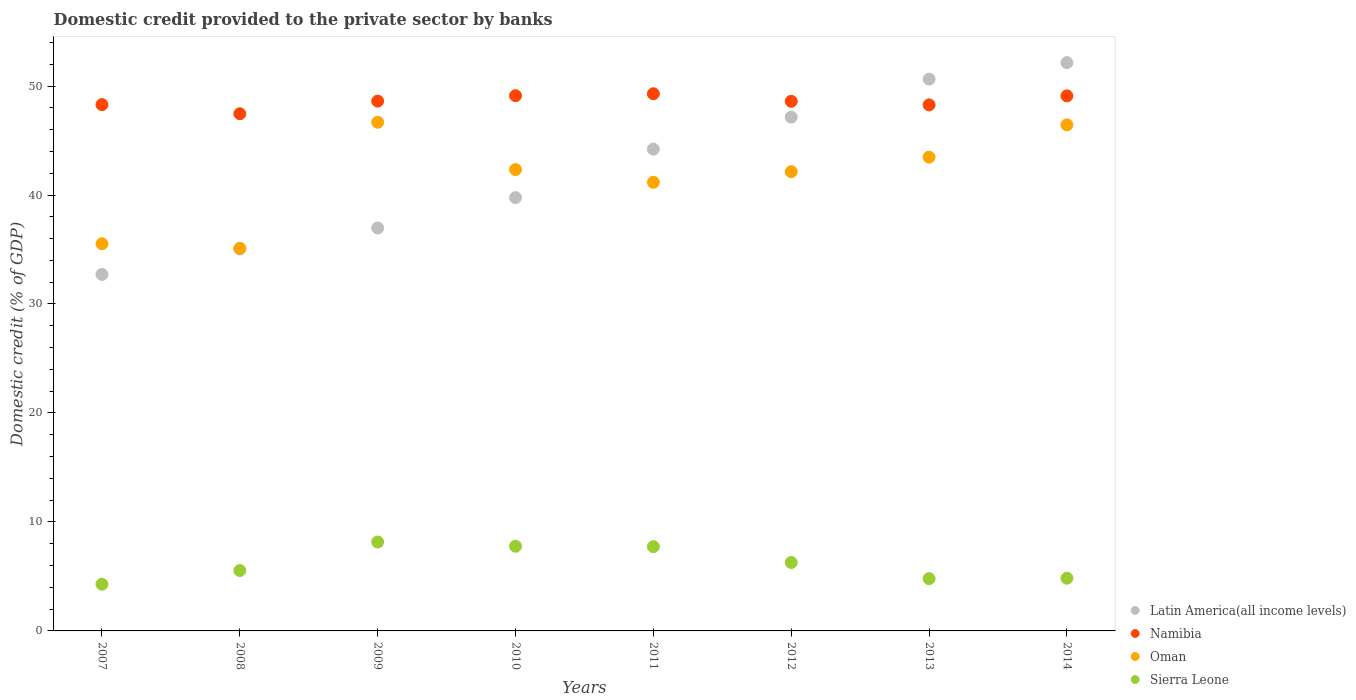How many different coloured dotlines are there?
Provide a short and direct response. 4. What is the domestic credit provided to the private sector by banks in Latin America(all income levels) in 2007?
Give a very brief answer. 32.71. Across all years, what is the maximum domestic credit provided to the private sector by banks in Sierra Leone?
Provide a succinct answer. 8.16. Across all years, what is the minimum domestic credit provided to the private sector by banks in Oman?
Provide a succinct answer. 35.11. What is the total domestic credit provided to the private sector by banks in Oman in the graph?
Your response must be concise. 332.86. What is the difference between the domestic credit provided to the private sector by banks in Oman in 2009 and that in 2010?
Make the answer very short. 4.34. What is the difference between the domestic credit provided to the private sector by banks in Latin America(all income levels) in 2009 and the domestic credit provided to the private sector by banks in Sierra Leone in 2008?
Keep it short and to the point. 31.44. What is the average domestic credit provided to the private sector by banks in Sierra Leone per year?
Your response must be concise. 6.17. In the year 2010, what is the difference between the domestic credit provided to the private sector by banks in Latin America(all income levels) and domestic credit provided to the private sector by banks in Oman?
Provide a short and direct response. -2.58. In how many years, is the domestic credit provided to the private sector by banks in Namibia greater than 2 %?
Your answer should be very brief. 8. What is the ratio of the domestic credit provided to the private sector by banks in Latin America(all income levels) in 2009 to that in 2014?
Your answer should be very brief. 0.71. What is the difference between the highest and the second highest domestic credit provided to the private sector by banks in Sierra Leone?
Offer a terse response. 0.39. What is the difference between the highest and the lowest domestic credit provided to the private sector by banks in Namibia?
Ensure brevity in your answer.  1.83. Is it the case that in every year, the sum of the domestic credit provided to the private sector by banks in Namibia and domestic credit provided to the private sector by banks in Sierra Leone  is greater than the sum of domestic credit provided to the private sector by banks in Latin America(all income levels) and domestic credit provided to the private sector by banks in Oman?
Your response must be concise. No. Is it the case that in every year, the sum of the domestic credit provided to the private sector by banks in Sierra Leone and domestic credit provided to the private sector by banks in Namibia  is greater than the domestic credit provided to the private sector by banks in Oman?
Offer a terse response. Yes. Does the domestic credit provided to the private sector by banks in Latin America(all income levels) monotonically increase over the years?
Keep it short and to the point. Yes. How many years are there in the graph?
Your response must be concise. 8. What is the difference between two consecutive major ticks on the Y-axis?
Keep it short and to the point. 10. Are the values on the major ticks of Y-axis written in scientific E-notation?
Offer a terse response. No. What is the title of the graph?
Your response must be concise. Domestic credit provided to the private sector by banks. Does "Latvia" appear as one of the legend labels in the graph?
Keep it short and to the point. No. What is the label or title of the Y-axis?
Provide a succinct answer. Domestic credit (% of GDP). What is the Domestic credit (% of GDP) of Latin America(all income levels) in 2007?
Your answer should be compact. 32.71. What is the Domestic credit (% of GDP) in Namibia in 2007?
Provide a succinct answer. 48.29. What is the Domestic credit (% of GDP) in Oman in 2007?
Provide a succinct answer. 35.53. What is the Domestic credit (% of GDP) in Sierra Leone in 2007?
Provide a succinct answer. 4.28. What is the Domestic credit (% of GDP) in Latin America(all income levels) in 2008?
Offer a terse response. 35.06. What is the Domestic credit (% of GDP) in Namibia in 2008?
Offer a very short reply. 47.46. What is the Domestic credit (% of GDP) of Oman in 2008?
Your answer should be compact. 35.11. What is the Domestic credit (% of GDP) of Sierra Leone in 2008?
Ensure brevity in your answer.  5.54. What is the Domestic credit (% of GDP) of Latin America(all income levels) in 2009?
Make the answer very short. 36.98. What is the Domestic credit (% of GDP) of Namibia in 2009?
Your answer should be very brief. 48.62. What is the Domestic credit (% of GDP) in Oman in 2009?
Your answer should be very brief. 46.68. What is the Domestic credit (% of GDP) of Sierra Leone in 2009?
Keep it short and to the point. 8.16. What is the Domestic credit (% of GDP) of Latin America(all income levels) in 2010?
Provide a succinct answer. 39.76. What is the Domestic credit (% of GDP) in Namibia in 2010?
Ensure brevity in your answer.  49.11. What is the Domestic credit (% of GDP) of Oman in 2010?
Provide a short and direct response. 42.33. What is the Domestic credit (% of GDP) in Sierra Leone in 2010?
Make the answer very short. 7.77. What is the Domestic credit (% of GDP) in Latin America(all income levels) in 2011?
Offer a terse response. 44.21. What is the Domestic credit (% of GDP) of Namibia in 2011?
Give a very brief answer. 49.29. What is the Domestic credit (% of GDP) in Oman in 2011?
Your response must be concise. 41.17. What is the Domestic credit (% of GDP) of Sierra Leone in 2011?
Offer a terse response. 7.73. What is the Domestic credit (% of GDP) of Latin America(all income levels) in 2012?
Provide a succinct answer. 47.15. What is the Domestic credit (% of GDP) of Namibia in 2012?
Your answer should be very brief. 48.6. What is the Domestic credit (% of GDP) of Oman in 2012?
Make the answer very short. 42.14. What is the Domestic credit (% of GDP) in Sierra Leone in 2012?
Your answer should be very brief. 6.28. What is the Domestic credit (% of GDP) of Latin America(all income levels) in 2013?
Give a very brief answer. 50.63. What is the Domestic credit (% of GDP) of Namibia in 2013?
Keep it short and to the point. 48.27. What is the Domestic credit (% of GDP) of Oman in 2013?
Your answer should be very brief. 43.47. What is the Domestic credit (% of GDP) in Sierra Leone in 2013?
Your answer should be very brief. 4.79. What is the Domestic credit (% of GDP) of Latin America(all income levels) in 2014?
Offer a very short reply. 52.14. What is the Domestic credit (% of GDP) in Namibia in 2014?
Make the answer very short. 49.1. What is the Domestic credit (% of GDP) in Oman in 2014?
Offer a very short reply. 46.44. What is the Domestic credit (% of GDP) of Sierra Leone in 2014?
Your response must be concise. 4.84. Across all years, what is the maximum Domestic credit (% of GDP) in Latin America(all income levels)?
Provide a succinct answer. 52.14. Across all years, what is the maximum Domestic credit (% of GDP) in Namibia?
Your response must be concise. 49.29. Across all years, what is the maximum Domestic credit (% of GDP) of Oman?
Offer a very short reply. 46.68. Across all years, what is the maximum Domestic credit (% of GDP) in Sierra Leone?
Your answer should be compact. 8.16. Across all years, what is the minimum Domestic credit (% of GDP) of Latin America(all income levels)?
Keep it short and to the point. 32.71. Across all years, what is the minimum Domestic credit (% of GDP) of Namibia?
Offer a very short reply. 47.46. Across all years, what is the minimum Domestic credit (% of GDP) in Oman?
Provide a short and direct response. 35.11. Across all years, what is the minimum Domestic credit (% of GDP) in Sierra Leone?
Make the answer very short. 4.28. What is the total Domestic credit (% of GDP) of Latin America(all income levels) in the graph?
Provide a short and direct response. 338.63. What is the total Domestic credit (% of GDP) of Namibia in the graph?
Provide a succinct answer. 388.74. What is the total Domestic credit (% of GDP) of Oman in the graph?
Ensure brevity in your answer.  332.86. What is the total Domestic credit (% of GDP) of Sierra Leone in the graph?
Offer a terse response. 49.4. What is the difference between the Domestic credit (% of GDP) of Latin America(all income levels) in 2007 and that in 2008?
Ensure brevity in your answer.  -2.35. What is the difference between the Domestic credit (% of GDP) in Namibia in 2007 and that in 2008?
Offer a terse response. 0.84. What is the difference between the Domestic credit (% of GDP) of Oman in 2007 and that in 2008?
Ensure brevity in your answer.  0.42. What is the difference between the Domestic credit (% of GDP) in Sierra Leone in 2007 and that in 2008?
Keep it short and to the point. -1.25. What is the difference between the Domestic credit (% of GDP) of Latin America(all income levels) in 2007 and that in 2009?
Offer a very short reply. -4.27. What is the difference between the Domestic credit (% of GDP) in Namibia in 2007 and that in 2009?
Offer a terse response. -0.32. What is the difference between the Domestic credit (% of GDP) of Oman in 2007 and that in 2009?
Give a very brief answer. -11.15. What is the difference between the Domestic credit (% of GDP) of Sierra Leone in 2007 and that in 2009?
Keep it short and to the point. -3.87. What is the difference between the Domestic credit (% of GDP) in Latin America(all income levels) in 2007 and that in 2010?
Make the answer very short. -7.05. What is the difference between the Domestic credit (% of GDP) of Namibia in 2007 and that in 2010?
Make the answer very short. -0.82. What is the difference between the Domestic credit (% of GDP) in Oman in 2007 and that in 2010?
Your answer should be compact. -6.81. What is the difference between the Domestic credit (% of GDP) in Sierra Leone in 2007 and that in 2010?
Your answer should be compact. -3.49. What is the difference between the Domestic credit (% of GDP) of Latin America(all income levels) in 2007 and that in 2011?
Make the answer very short. -11.5. What is the difference between the Domestic credit (% of GDP) in Namibia in 2007 and that in 2011?
Give a very brief answer. -1. What is the difference between the Domestic credit (% of GDP) in Oman in 2007 and that in 2011?
Provide a short and direct response. -5.64. What is the difference between the Domestic credit (% of GDP) of Sierra Leone in 2007 and that in 2011?
Your response must be concise. -3.45. What is the difference between the Domestic credit (% of GDP) of Latin America(all income levels) in 2007 and that in 2012?
Your answer should be very brief. -14.44. What is the difference between the Domestic credit (% of GDP) of Namibia in 2007 and that in 2012?
Offer a terse response. -0.3. What is the difference between the Domestic credit (% of GDP) in Oman in 2007 and that in 2012?
Provide a short and direct response. -6.61. What is the difference between the Domestic credit (% of GDP) of Sierra Leone in 2007 and that in 2012?
Offer a very short reply. -1.99. What is the difference between the Domestic credit (% of GDP) in Latin America(all income levels) in 2007 and that in 2013?
Provide a short and direct response. -17.93. What is the difference between the Domestic credit (% of GDP) in Namibia in 2007 and that in 2013?
Your response must be concise. 0.02. What is the difference between the Domestic credit (% of GDP) in Oman in 2007 and that in 2013?
Keep it short and to the point. -7.95. What is the difference between the Domestic credit (% of GDP) of Sierra Leone in 2007 and that in 2013?
Make the answer very short. -0.51. What is the difference between the Domestic credit (% of GDP) of Latin America(all income levels) in 2007 and that in 2014?
Ensure brevity in your answer.  -19.44. What is the difference between the Domestic credit (% of GDP) in Namibia in 2007 and that in 2014?
Make the answer very short. -0.8. What is the difference between the Domestic credit (% of GDP) of Oman in 2007 and that in 2014?
Give a very brief answer. -10.91. What is the difference between the Domestic credit (% of GDP) in Sierra Leone in 2007 and that in 2014?
Give a very brief answer. -0.55. What is the difference between the Domestic credit (% of GDP) in Latin America(all income levels) in 2008 and that in 2009?
Offer a terse response. -1.92. What is the difference between the Domestic credit (% of GDP) of Namibia in 2008 and that in 2009?
Provide a short and direct response. -1.16. What is the difference between the Domestic credit (% of GDP) of Oman in 2008 and that in 2009?
Your response must be concise. -11.57. What is the difference between the Domestic credit (% of GDP) of Sierra Leone in 2008 and that in 2009?
Keep it short and to the point. -2.62. What is the difference between the Domestic credit (% of GDP) of Latin America(all income levels) in 2008 and that in 2010?
Your answer should be very brief. -4.7. What is the difference between the Domestic credit (% of GDP) of Namibia in 2008 and that in 2010?
Make the answer very short. -1.65. What is the difference between the Domestic credit (% of GDP) of Oman in 2008 and that in 2010?
Give a very brief answer. -7.23. What is the difference between the Domestic credit (% of GDP) in Sierra Leone in 2008 and that in 2010?
Give a very brief answer. -2.23. What is the difference between the Domestic credit (% of GDP) in Latin America(all income levels) in 2008 and that in 2011?
Provide a succinct answer. -9.15. What is the difference between the Domestic credit (% of GDP) in Namibia in 2008 and that in 2011?
Offer a very short reply. -1.83. What is the difference between the Domestic credit (% of GDP) of Oman in 2008 and that in 2011?
Your answer should be compact. -6.06. What is the difference between the Domestic credit (% of GDP) in Sierra Leone in 2008 and that in 2011?
Provide a short and direct response. -2.19. What is the difference between the Domestic credit (% of GDP) of Latin America(all income levels) in 2008 and that in 2012?
Offer a very short reply. -12.09. What is the difference between the Domestic credit (% of GDP) in Namibia in 2008 and that in 2012?
Provide a short and direct response. -1.14. What is the difference between the Domestic credit (% of GDP) in Oman in 2008 and that in 2012?
Your response must be concise. -7.03. What is the difference between the Domestic credit (% of GDP) of Sierra Leone in 2008 and that in 2012?
Provide a short and direct response. -0.74. What is the difference between the Domestic credit (% of GDP) of Latin America(all income levels) in 2008 and that in 2013?
Give a very brief answer. -15.58. What is the difference between the Domestic credit (% of GDP) of Namibia in 2008 and that in 2013?
Keep it short and to the point. -0.81. What is the difference between the Domestic credit (% of GDP) in Oman in 2008 and that in 2013?
Your answer should be very brief. -8.36. What is the difference between the Domestic credit (% of GDP) in Sierra Leone in 2008 and that in 2013?
Your response must be concise. 0.74. What is the difference between the Domestic credit (% of GDP) in Latin America(all income levels) in 2008 and that in 2014?
Offer a terse response. -17.09. What is the difference between the Domestic credit (% of GDP) of Namibia in 2008 and that in 2014?
Provide a succinct answer. -1.64. What is the difference between the Domestic credit (% of GDP) in Oman in 2008 and that in 2014?
Provide a short and direct response. -11.33. What is the difference between the Domestic credit (% of GDP) of Sierra Leone in 2008 and that in 2014?
Make the answer very short. 0.7. What is the difference between the Domestic credit (% of GDP) of Latin America(all income levels) in 2009 and that in 2010?
Offer a very short reply. -2.78. What is the difference between the Domestic credit (% of GDP) in Namibia in 2009 and that in 2010?
Offer a very short reply. -0.49. What is the difference between the Domestic credit (% of GDP) of Oman in 2009 and that in 2010?
Your answer should be very brief. 4.34. What is the difference between the Domestic credit (% of GDP) of Sierra Leone in 2009 and that in 2010?
Make the answer very short. 0.39. What is the difference between the Domestic credit (% of GDP) in Latin America(all income levels) in 2009 and that in 2011?
Your response must be concise. -7.23. What is the difference between the Domestic credit (% of GDP) of Namibia in 2009 and that in 2011?
Give a very brief answer. -0.67. What is the difference between the Domestic credit (% of GDP) in Oman in 2009 and that in 2011?
Your answer should be very brief. 5.51. What is the difference between the Domestic credit (% of GDP) of Sierra Leone in 2009 and that in 2011?
Provide a short and direct response. 0.43. What is the difference between the Domestic credit (% of GDP) in Latin America(all income levels) in 2009 and that in 2012?
Ensure brevity in your answer.  -10.17. What is the difference between the Domestic credit (% of GDP) of Namibia in 2009 and that in 2012?
Ensure brevity in your answer.  0.02. What is the difference between the Domestic credit (% of GDP) in Oman in 2009 and that in 2012?
Offer a terse response. 4.54. What is the difference between the Domestic credit (% of GDP) in Sierra Leone in 2009 and that in 2012?
Provide a short and direct response. 1.88. What is the difference between the Domestic credit (% of GDP) in Latin America(all income levels) in 2009 and that in 2013?
Offer a terse response. -13.66. What is the difference between the Domestic credit (% of GDP) of Namibia in 2009 and that in 2013?
Offer a very short reply. 0.35. What is the difference between the Domestic credit (% of GDP) of Oman in 2009 and that in 2013?
Your answer should be compact. 3.2. What is the difference between the Domestic credit (% of GDP) in Sierra Leone in 2009 and that in 2013?
Your answer should be very brief. 3.36. What is the difference between the Domestic credit (% of GDP) in Latin America(all income levels) in 2009 and that in 2014?
Offer a terse response. -15.17. What is the difference between the Domestic credit (% of GDP) in Namibia in 2009 and that in 2014?
Keep it short and to the point. -0.48. What is the difference between the Domestic credit (% of GDP) in Oman in 2009 and that in 2014?
Offer a terse response. 0.24. What is the difference between the Domestic credit (% of GDP) in Sierra Leone in 2009 and that in 2014?
Keep it short and to the point. 3.32. What is the difference between the Domestic credit (% of GDP) of Latin America(all income levels) in 2010 and that in 2011?
Keep it short and to the point. -4.45. What is the difference between the Domestic credit (% of GDP) in Namibia in 2010 and that in 2011?
Provide a short and direct response. -0.18. What is the difference between the Domestic credit (% of GDP) in Oman in 2010 and that in 2011?
Your response must be concise. 1.17. What is the difference between the Domestic credit (% of GDP) of Sierra Leone in 2010 and that in 2011?
Give a very brief answer. 0.04. What is the difference between the Domestic credit (% of GDP) of Latin America(all income levels) in 2010 and that in 2012?
Provide a succinct answer. -7.39. What is the difference between the Domestic credit (% of GDP) of Namibia in 2010 and that in 2012?
Ensure brevity in your answer.  0.51. What is the difference between the Domestic credit (% of GDP) in Oman in 2010 and that in 2012?
Make the answer very short. 0.19. What is the difference between the Domestic credit (% of GDP) in Sierra Leone in 2010 and that in 2012?
Provide a short and direct response. 1.49. What is the difference between the Domestic credit (% of GDP) of Latin America(all income levels) in 2010 and that in 2013?
Your answer should be very brief. -10.88. What is the difference between the Domestic credit (% of GDP) of Namibia in 2010 and that in 2013?
Your response must be concise. 0.84. What is the difference between the Domestic credit (% of GDP) of Oman in 2010 and that in 2013?
Provide a succinct answer. -1.14. What is the difference between the Domestic credit (% of GDP) in Sierra Leone in 2010 and that in 2013?
Your response must be concise. 2.98. What is the difference between the Domestic credit (% of GDP) of Latin America(all income levels) in 2010 and that in 2014?
Provide a short and direct response. -12.39. What is the difference between the Domestic credit (% of GDP) in Namibia in 2010 and that in 2014?
Keep it short and to the point. 0.02. What is the difference between the Domestic credit (% of GDP) of Oman in 2010 and that in 2014?
Offer a very short reply. -4.1. What is the difference between the Domestic credit (% of GDP) in Sierra Leone in 2010 and that in 2014?
Give a very brief answer. 2.93. What is the difference between the Domestic credit (% of GDP) of Latin America(all income levels) in 2011 and that in 2012?
Provide a short and direct response. -2.94. What is the difference between the Domestic credit (% of GDP) of Namibia in 2011 and that in 2012?
Give a very brief answer. 0.69. What is the difference between the Domestic credit (% of GDP) of Oman in 2011 and that in 2012?
Provide a short and direct response. -0.97. What is the difference between the Domestic credit (% of GDP) of Sierra Leone in 2011 and that in 2012?
Keep it short and to the point. 1.45. What is the difference between the Domestic credit (% of GDP) in Latin America(all income levels) in 2011 and that in 2013?
Your response must be concise. -6.43. What is the difference between the Domestic credit (% of GDP) of Namibia in 2011 and that in 2013?
Your response must be concise. 1.02. What is the difference between the Domestic credit (% of GDP) in Oman in 2011 and that in 2013?
Make the answer very short. -2.31. What is the difference between the Domestic credit (% of GDP) in Sierra Leone in 2011 and that in 2013?
Provide a succinct answer. 2.94. What is the difference between the Domestic credit (% of GDP) of Latin America(all income levels) in 2011 and that in 2014?
Provide a short and direct response. -7.94. What is the difference between the Domestic credit (% of GDP) in Namibia in 2011 and that in 2014?
Offer a terse response. 0.19. What is the difference between the Domestic credit (% of GDP) in Oman in 2011 and that in 2014?
Provide a succinct answer. -5.27. What is the difference between the Domestic credit (% of GDP) in Sierra Leone in 2011 and that in 2014?
Offer a terse response. 2.89. What is the difference between the Domestic credit (% of GDP) of Latin America(all income levels) in 2012 and that in 2013?
Ensure brevity in your answer.  -3.49. What is the difference between the Domestic credit (% of GDP) in Namibia in 2012 and that in 2013?
Your answer should be compact. 0.33. What is the difference between the Domestic credit (% of GDP) of Oman in 2012 and that in 2013?
Your answer should be very brief. -1.33. What is the difference between the Domestic credit (% of GDP) of Sierra Leone in 2012 and that in 2013?
Ensure brevity in your answer.  1.48. What is the difference between the Domestic credit (% of GDP) of Latin America(all income levels) in 2012 and that in 2014?
Provide a succinct answer. -5. What is the difference between the Domestic credit (% of GDP) in Namibia in 2012 and that in 2014?
Your answer should be very brief. -0.5. What is the difference between the Domestic credit (% of GDP) of Oman in 2012 and that in 2014?
Provide a short and direct response. -4.3. What is the difference between the Domestic credit (% of GDP) of Sierra Leone in 2012 and that in 2014?
Provide a short and direct response. 1.44. What is the difference between the Domestic credit (% of GDP) in Latin America(all income levels) in 2013 and that in 2014?
Offer a very short reply. -1.51. What is the difference between the Domestic credit (% of GDP) of Namibia in 2013 and that in 2014?
Your answer should be very brief. -0.82. What is the difference between the Domestic credit (% of GDP) in Oman in 2013 and that in 2014?
Ensure brevity in your answer.  -2.97. What is the difference between the Domestic credit (% of GDP) in Sierra Leone in 2013 and that in 2014?
Keep it short and to the point. -0.04. What is the difference between the Domestic credit (% of GDP) in Latin America(all income levels) in 2007 and the Domestic credit (% of GDP) in Namibia in 2008?
Make the answer very short. -14.75. What is the difference between the Domestic credit (% of GDP) of Latin America(all income levels) in 2007 and the Domestic credit (% of GDP) of Oman in 2008?
Your response must be concise. -2.4. What is the difference between the Domestic credit (% of GDP) of Latin America(all income levels) in 2007 and the Domestic credit (% of GDP) of Sierra Leone in 2008?
Ensure brevity in your answer.  27.17. What is the difference between the Domestic credit (% of GDP) of Namibia in 2007 and the Domestic credit (% of GDP) of Oman in 2008?
Keep it short and to the point. 13.19. What is the difference between the Domestic credit (% of GDP) of Namibia in 2007 and the Domestic credit (% of GDP) of Sierra Leone in 2008?
Keep it short and to the point. 42.76. What is the difference between the Domestic credit (% of GDP) in Oman in 2007 and the Domestic credit (% of GDP) in Sierra Leone in 2008?
Offer a very short reply. 29.99. What is the difference between the Domestic credit (% of GDP) of Latin America(all income levels) in 2007 and the Domestic credit (% of GDP) of Namibia in 2009?
Your answer should be very brief. -15.91. What is the difference between the Domestic credit (% of GDP) of Latin America(all income levels) in 2007 and the Domestic credit (% of GDP) of Oman in 2009?
Offer a terse response. -13.97. What is the difference between the Domestic credit (% of GDP) of Latin America(all income levels) in 2007 and the Domestic credit (% of GDP) of Sierra Leone in 2009?
Give a very brief answer. 24.55. What is the difference between the Domestic credit (% of GDP) of Namibia in 2007 and the Domestic credit (% of GDP) of Oman in 2009?
Provide a succinct answer. 1.62. What is the difference between the Domestic credit (% of GDP) in Namibia in 2007 and the Domestic credit (% of GDP) in Sierra Leone in 2009?
Your response must be concise. 40.14. What is the difference between the Domestic credit (% of GDP) of Oman in 2007 and the Domestic credit (% of GDP) of Sierra Leone in 2009?
Ensure brevity in your answer.  27.37. What is the difference between the Domestic credit (% of GDP) of Latin America(all income levels) in 2007 and the Domestic credit (% of GDP) of Namibia in 2010?
Your answer should be very brief. -16.4. What is the difference between the Domestic credit (% of GDP) of Latin America(all income levels) in 2007 and the Domestic credit (% of GDP) of Oman in 2010?
Give a very brief answer. -9.63. What is the difference between the Domestic credit (% of GDP) in Latin America(all income levels) in 2007 and the Domestic credit (% of GDP) in Sierra Leone in 2010?
Ensure brevity in your answer.  24.94. What is the difference between the Domestic credit (% of GDP) in Namibia in 2007 and the Domestic credit (% of GDP) in Oman in 2010?
Provide a short and direct response. 5.96. What is the difference between the Domestic credit (% of GDP) of Namibia in 2007 and the Domestic credit (% of GDP) of Sierra Leone in 2010?
Make the answer very short. 40.52. What is the difference between the Domestic credit (% of GDP) of Oman in 2007 and the Domestic credit (% of GDP) of Sierra Leone in 2010?
Provide a succinct answer. 27.76. What is the difference between the Domestic credit (% of GDP) in Latin America(all income levels) in 2007 and the Domestic credit (% of GDP) in Namibia in 2011?
Give a very brief answer. -16.58. What is the difference between the Domestic credit (% of GDP) of Latin America(all income levels) in 2007 and the Domestic credit (% of GDP) of Oman in 2011?
Your response must be concise. -8.46. What is the difference between the Domestic credit (% of GDP) in Latin America(all income levels) in 2007 and the Domestic credit (% of GDP) in Sierra Leone in 2011?
Your answer should be compact. 24.98. What is the difference between the Domestic credit (% of GDP) in Namibia in 2007 and the Domestic credit (% of GDP) in Oman in 2011?
Provide a short and direct response. 7.13. What is the difference between the Domestic credit (% of GDP) of Namibia in 2007 and the Domestic credit (% of GDP) of Sierra Leone in 2011?
Keep it short and to the point. 40.56. What is the difference between the Domestic credit (% of GDP) of Oman in 2007 and the Domestic credit (% of GDP) of Sierra Leone in 2011?
Your answer should be compact. 27.8. What is the difference between the Domestic credit (% of GDP) in Latin America(all income levels) in 2007 and the Domestic credit (% of GDP) in Namibia in 2012?
Provide a succinct answer. -15.89. What is the difference between the Domestic credit (% of GDP) of Latin America(all income levels) in 2007 and the Domestic credit (% of GDP) of Oman in 2012?
Keep it short and to the point. -9.43. What is the difference between the Domestic credit (% of GDP) of Latin America(all income levels) in 2007 and the Domestic credit (% of GDP) of Sierra Leone in 2012?
Your response must be concise. 26.43. What is the difference between the Domestic credit (% of GDP) in Namibia in 2007 and the Domestic credit (% of GDP) in Oman in 2012?
Your response must be concise. 6.15. What is the difference between the Domestic credit (% of GDP) in Namibia in 2007 and the Domestic credit (% of GDP) in Sierra Leone in 2012?
Your answer should be compact. 42.02. What is the difference between the Domestic credit (% of GDP) of Oman in 2007 and the Domestic credit (% of GDP) of Sierra Leone in 2012?
Provide a short and direct response. 29.25. What is the difference between the Domestic credit (% of GDP) of Latin America(all income levels) in 2007 and the Domestic credit (% of GDP) of Namibia in 2013?
Ensure brevity in your answer.  -15.56. What is the difference between the Domestic credit (% of GDP) of Latin America(all income levels) in 2007 and the Domestic credit (% of GDP) of Oman in 2013?
Ensure brevity in your answer.  -10.76. What is the difference between the Domestic credit (% of GDP) of Latin America(all income levels) in 2007 and the Domestic credit (% of GDP) of Sierra Leone in 2013?
Make the answer very short. 27.91. What is the difference between the Domestic credit (% of GDP) in Namibia in 2007 and the Domestic credit (% of GDP) in Oman in 2013?
Give a very brief answer. 4.82. What is the difference between the Domestic credit (% of GDP) in Namibia in 2007 and the Domestic credit (% of GDP) in Sierra Leone in 2013?
Ensure brevity in your answer.  43.5. What is the difference between the Domestic credit (% of GDP) of Oman in 2007 and the Domestic credit (% of GDP) of Sierra Leone in 2013?
Offer a very short reply. 30.73. What is the difference between the Domestic credit (% of GDP) of Latin America(all income levels) in 2007 and the Domestic credit (% of GDP) of Namibia in 2014?
Keep it short and to the point. -16.39. What is the difference between the Domestic credit (% of GDP) in Latin America(all income levels) in 2007 and the Domestic credit (% of GDP) in Oman in 2014?
Keep it short and to the point. -13.73. What is the difference between the Domestic credit (% of GDP) of Latin America(all income levels) in 2007 and the Domestic credit (% of GDP) of Sierra Leone in 2014?
Provide a succinct answer. 27.87. What is the difference between the Domestic credit (% of GDP) of Namibia in 2007 and the Domestic credit (% of GDP) of Oman in 2014?
Provide a short and direct response. 1.86. What is the difference between the Domestic credit (% of GDP) in Namibia in 2007 and the Domestic credit (% of GDP) in Sierra Leone in 2014?
Offer a terse response. 43.46. What is the difference between the Domestic credit (% of GDP) in Oman in 2007 and the Domestic credit (% of GDP) in Sierra Leone in 2014?
Provide a succinct answer. 30.69. What is the difference between the Domestic credit (% of GDP) of Latin America(all income levels) in 2008 and the Domestic credit (% of GDP) of Namibia in 2009?
Offer a terse response. -13.56. What is the difference between the Domestic credit (% of GDP) in Latin America(all income levels) in 2008 and the Domestic credit (% of GDP) in Oman in 2009?
Your answer should be very brief. -11.62. What is the difference between the Domestic credit (% of GDP) of Latin America(all income levels) in 2008 and the Domestic credit (% of GDP) of Sierra Leone in 2009?
Your answer should be very brief. 26.9. What is the difference between the Domestic credit (% of GDP) of Namibia in 2008 and the Domestic credit (% of GDP) of Oman in 2009?
Ensure brevity in your answer.  0.78. What is the difference between the Domestic credit (% of GDP) in Namibia in 2008 and the Domestic credit (% of GDP) in Sierra Leone in 2009?
Provide a short and direct response. 39.3. What is the difference between the Domestic credit (% of GDP) of Oman in 2008 and the Domestic credit (% of GDP) of Sierra Leone in 2009?
Provide a succinct answer. 26.95. What is the difference between the Domestic credit (% of GDP) of Latin America(all income levels) in 2008 and the Domestic credit (% of GDP) of Namibia in 2010?
Give a very brief answer. -14.05. What is the difference between the Domestic credit (% of GDP) in Latin America(all income levels) in 2008 and the Domestic credit (% of GDP) in Oman in 2010?
Provide a short and direct response. -7.28. What is the difference between the Domestic credit (% of GDP) in Latin America(all income levels) in 2008 and the Domestic credit (% of GDP) in Sierra Leone in 2010?
Ensure brevity in your answer.  27.29. What is the difference between the Domestic credit (% of GDP) of Namibia in 2008 and the Domestic credit (% of GDP) of Oman in 2010?
Keep it short and to the point. 5.12. What is the difference between the Domestic credit (% of GDP) in Namibia in 2008 and the Domestic credit (% of GDP) in Sierra Leone in 2010?
Your answer should be very brief. 39.69. What is the difference between the Domestic credit (% of GDP) of Oman in 2008 and the Domestic credit (% of GDP) of Sierra Leone in 2010?
Make the answer very short. 27.34. What is the difference between the Domestic credit (% of GDP) in Latin America(all income levels) in 2008 and the Domestic credit (% of GDP) in Namibia in 2011?
Keep it short and to the point. -14.23. What is the difference between the Domestic credit (% of GDP) in Latin America(all income levels) in 2008 and the Domestic credit (% of GDP) in Oman in 2011?
Your response must be concise. -6.11. What is the difference between the Domestic credit (% of GDP) of Latin America(all income levels) in 2008 and the Domestic credit (% of GDP) of Sierra Leone in 2011?
Offer a terse response. 27.32. What is the difference between the Domestic credit (% of GDP) in Namibia in 2008 and the Domestic credit (% of GDP) in Oman in 2011?
Keep it short and to the point. 6.29. What is the difference between the Domestic credit (% of GDP) of Namibia in 2008 and the Domestic credit (% of GDP) of Sierra Leone in 2011?
Your answer should be very brief. 39.72. What is the difference between the Domestic credit (% of GDP) of Oman in 2008 and the Domestic credit (% of GDP) of Sierra Leone in 2011?
Provide a succinct answer. 27.38. What is the difference between the Domestic credit (% of GDP) of Latin America(all income levels) in 2008 and the Domestic credit (% of GDP) of Namibia in 2012?
Your response must be concise. -13.54. What is the difference between the Domestic credit (% of GDP) of Latin America(all income levels) in 2008 and the Domestic credit (% of GDP) of Oman in 2012?
Your answer should be compact. -7.08. What is the difference between the Domestic credit (% of GDP) of Latin America(all income levels) in 2008 and the Domestic credit (% of GDP) of Sierra Leone in 2012?
Your answer should be compact. 28.78. What is the difference between the Domestic credit (% of GDP) in Namibia in 2008 and the Domestic credit (% of GDP) in Oman in 2012?
Make the answer very short. 5.32. What is the difference between the Domestic credit (% of GDP) of Namibia in 2008 and the Domestic credit (% of GDP) of Sierra Leone in 2012?
Keep it short and to the point. 41.18. What is the difference between the Domestic credit (% of GDP) of Oman in 2008 and the Domestic credit (% of GDP) of Sierra Leone in 2012?
Your response must be concise. 28.83. What is the difference between the Domestic credit (% of GDP) of Latin America(all income levels) in 2008 and the Domestic credit (% of GDP) of Namibia in 2013?
Keep it short and to the point. -13.21. What is the difference between the Domestic credit (% of GDP) of Latin America(all income levels) in 2008 and the Domestic credit (% of GDP) of Oman in 2013?
Your answer should be very brief. -8.42. What is the difference between the Domestic credit (% of GDP) in Latin America(all income levels) in 2008 and the Domestic credit (% of GDP) in Sierra Leone in 2013?
Your answer should be compact. 30.26. What is the difference between the Domestic credit (% of GDP) in Namibia in 2008 and the Domestic credit (% of GDP) in Oman in 2013?
Ensure brevity in your answer.  3.98. What is the difference between the Domestic credit (% of GDP) in Namibia in 2008 and the Domestic credit (% of GDP) in Sierra Leone in 2013?
Make the answer very short. 42.66. What is the difference between the Domestic credit (% of GDP) in Oman in 2008 and the Domestic credit (% of GDP) in Sierra Leone in 2013?
Offer a terse response. 30.31. What is the difference between the Domestic credit (% of GDP) in Latin America(all income levels) in 2008 and the Domestic credit (% of GDP) in Namibia in 2014?
Your response must be concise. -14.04. What is the difference between the Domestic credit (% of GDP) of Latin America(all income levels) in 2008 and the Domestic credit (% of GDP) of Oman in 2014?
Provide a succinct answer. -11.38. What is the difference between the Domestic credit (% of GDP) in Latin America(all income levels) in 2008 and the Domestic credit (% of GDP) in Sierra Leone in 2014?
Your answer should be very brief. 30.22. What is the difference between the Domestic credit (% of GDP) in Namibia in 2008 and the Domestic credit (% of GDP) in Oman in 2014?
Offer a very short reply. 1.02. What is the difference between the Domestic credit (% of GDP) in Namibia in 2008 and the Domestic credit (% of GDP) in Sierra Leone in 2014?
Offer a terse response. 42.62. What is the difference between the Domestic credit (% of GDP) of Oman in 2008 and the Domestic credit (% of GDP) of Sierra Leone in 2014?
Give a very brief answer. 30.27. What is the difference between the Domestic credit (% of GDP) in Latin America(all income levels) in 2009 and the Domestic credit (% of GDP) in Namibia in 2010?
Provide a short and direct response. -12.14. What is the difference between the Domestic credit (% of GDP) of Latin America(all income levels) in 2009 and the Domestic credit (% of GDP) of Oman in 2010?
Offer a very short reply. -5.36. What is the difference between the Domestic credit (% of GDP) of Latin America(all income levels) in 2009 and the Domestic credit (% of GDP) of Sierra Leone in 2010?
Your answer should be very brief. 29.2. What is the difference between the Domestic credit (% of GDP) in Namibia in 2009 and the Domestic credit (% of GDP) in Oman in 2010?
Make the answer very short. 6.28. What is the difference between the Domestic credit (% of GDP) of Namibia in 2009 and the Domestic credit (% of GDP) of Sierra Leone in 2010?
Provide a succinct answer. 40.85. What is the difference between the Domestic credit (% of GDP) of Oman in 2009 and the Domestic credit (% of GDP) of Sierra Leone in 2010?
Provide a succinct answer. 38.9. What is the difference between the Domestic credit (% of GDP) of Latin America(all income levels) in 2009 and the Domestic credit (% of GDP) of Namibia in 2011?
Your response must be concise. -12.31. What is the difference between the Domestic credit (% of GDP) in Latin America(all income levels) in 2009 and the Domestic credit (% of GDP) in Oman in 2011?
Your answer should be compact. -4.19. What is the difference between the Domestic credit (% of GDP) of Latin America(all income levels) in 2009 and the Domestic credit (% of GDP) of Sierra Leone in 2011?
Ensure brevity in your answer.  29.24. What is the difference between the Domestic credit (% of GDP) in Namibia in 2009 and the Domestic credit (% of GDP) in Oman in 2011?
Your response must be concise. 7.45. What is the difference between the Domestic credit (% of GDP) in Namibia in 2009 and the Domestic credit (% of GDP) in Sierra Leone in 2011?
Ensure brevity in your answer.  40.89. What is the difference between the Domestic credit (% of GDP) in Oman in 2009 and the Domestic credit (% of GDP) in Sierra Leone in 2011?
Your answer should be compact. 38.94. What is the difference between the Domestic credit (% of GDP) in Latin America(all income levels) in 2009 and the Domestic credit (% of GDP) in Namibia in 2012?
Your answer should be compact. -11.62. What is the difference between the Domestic credit (% of GDP) in Latin America(all income levels) in 2009 and the Domestic credit (% of GDP) in Oman in 2012?
Offer a very short reply. -5.16. What is the difference between the Domestic credit (% of GDP) of Latin America(all income levels) in 2009 and the Domestic credit (% of GDP) of Sierra Leone in 2012?
Provide a short and direct response. 30.7. What is the difference between the Domestic credit (% of GDP) of Namibia in 2009 and the Domestic credit (% of GDP) of Oman in 2012?
Your answer should be very brief. 6.48. What is the difference between the Domestic credit (% of GDP) of Namibia in 2009 and the Domestic credit (% of GDP) of Sierra Leone in 2012?
Give a very brief answer. 42.34. What is the difference between the Domestic credit (% of GDP) in Oman in 2009 and the Domestic credit (% of GDP) in Sierra Leone in 2012?
Keep it short and to the point. 40.4. What is the difference between the Domestic credit (% of GDP) in Latin America(all income levels) in 2009 and the Domestic credit (% of GDP) in Namibia in 2013?
Keep it short and to the point. -11.3. What is the difference between the Domestic credit (% of GDP) in Latin America(all income levels) in 2009 and the Domestic credit (% of GDP) in Oman in 2013?
Offer a terse response. -6.5. What is the difference between the Domestic credit (% of GDP) in Latin America(all income levels) in 2009 and the Domestic credit (% of GDP) in Sierra Leone in 2013?
Your answer should be compact. 32.18. What is the difference between the Domestic credit (% of GDP) of Namibia in 2009 and the Domestic credit (% of GDP) of Oman in 2013?
Offer a very short reply. 5.15. What is the difference between the Domestic credit (% of GDP) of Namibia in 2009 and the Domestic credit (% of GDP) of Sierra Leone in 2013?
Offer a very short reply. 43.82. What is the difference between the Domestic credit (% of GDP) in Oman in 2009 and the Domestic credit (% of GDP) in Sierra Leone in 2013?
Offer a terse response. 41.88. What is the difference between the Domestic credit (% of GDP) of Latin America(all income levels) in 2009 and the Domestic credit (% of GDP) of Namibia in 2014?
Make the answer very short. -12.12. What is the difference between the Domestic credit (% of GDP) in Latin America(all income levels) in 2009 and the Domestic credit (% of GDP) in Oman in 2014?
Provide a short and direct response. -9.46. What is the difference between the Domestic credit (% of GDP) in Latin America(all income levels) in 2009 and the Domestic credit (% of GDP) in Sierra Leone in 2014?
Offer a very short reply. 32.14. What is the difference between the Domestic credit (% of GDP) of Namibia in 2009 and the Domestic credit (% of GDP) of Oman in 2014?
Your response must be concise. 2.18. What is the difference between the Domestic credit (% of GDP) of Namibia in 2009 and the Domestic credit (% of GDP) of Sierra Leone in 2014?
Provide a short and direct response. 43.78. What is the difference between the Domestic credit (% of GDP) of Oman in 2009 and the Domestic credit (% of GDP) of Sierra Leone in 2014?
Offer a very short reply. 41.84. What is the difference between the Domestic credit (% of GDP) of Latin America(all income levels) in 2010 and the Domestic credit (% of GDP) of Namibia in 2011?
Provide a short and direct response. -9.53. What is the difference between the Domestic credit (% of GDP) of Latin America(all income levels) in 2010 and the Domestic credit (% of GDP) of Oman in 2011?
Ensure brevity in your answer.  -1.41. What is the difference between the Domestic credit (% of GDP) in Latin America(all income levels) in 2010 and the Domestic credit (% of GDP) in Sierra Leone in 2011?
Keep it short and to the point. 32.02. What is the difference between the Domestic credit (% of GDP) of Namibia in 2010 and the Domestic credit (% of GDP) of Oman in 2011?
Make the answer very short. 7.95. What is the difference between the Domestic credit (% of GDP) of Namibia in 2010 and the Domestic credit (% of GDP) of Sierra Leone in 2011?
Give a very brief answer. 41.38. What is the difference between the Domestic credit (% of GDP) in Oman in 2010 and the Domestic credit (% of GDP) in Sierra Leone in 2011?
Offer a terse response. 34.6. What is the difference between the Domestic credit (% of GDP) in Latin America(all income levels) in 2010 and the Domestic credit (% of GDP) in Namibia in 2012?
Provide a succinct answer. -8.84. What is the difference between the Domestic credit (% of GDP) of Latin America(all income levels) in 2010 and the Domestic credit (% of GDP) of Oman in 2012?
Your response must be concise. -2.38. What is the difference between the Domestic credit (% of GDP) in Latin America(all income levels) in 2010 and the Domestic credit (% of GDP) in Sierra Leone in 2012?
Provide a short and direct response. 33.48. What is the difference between the Domestic credit (% of GDP) of Namibia in 2010 and the Domestic credit (% of GDP) of Oman in 2012?
Your response must be concise. 6.97. What is the difference between the Domestic credit (% of GDP) in Namibia in 2010 and the Domestic credit (% of GDP) in Sierra Leone in 2012?
Offer a very short reply. 42.83. What is the difference between the Domestic credit (% of GDP) in Oman in 2010 and the Domestic credit (% of GDP) in Sierra Leone in 2012?
Provide a succinct answer. 36.06. What is the difference between the Domestic credit (% of GDP) of Latin America(all income levels) in 2010 and the Domestic credit (% of GDP) of Namibia in 2013?
Your answer should be very brief. -8.52. What is the difference between the Domestic credit (% of GDP) in Latin America(all income levels) in 2010 and the Domestic credit (% of GDP) in Oman in 2013?
Offer a very short reply. -3.72. What is the difference between the Domestic credit (% of GDP) in Latin America(all income levels) in 2010 and the Domestic credit (% of GDP) in Sierra Leone in 2013?
Ensure brevity in your answer.  34.96. What is the difference between the Domestic credit (% of GDP) of Namibia in 2010 and the Domestic credit (% of GDP) of Oman in 2013?
Keep it short and to the point. 5.64. What is the difference between the Domestic credit (% of GDP) of Namibia in 2010 and the Domestic credit (% of GDP) of Sierra Leone in 2013?
Provide a succinct answer. 44.32. What is the difference between the Domestic credit (% of GDP) in Oman in 2010 and the Domestic credit (% of GDP) in Sierra Leone in 2013?
Provide a succinct answer. 37.54. What is the difference between the Domestic credit (% of GDP) of Latin America(all income levels) in 2010 and the Domestic credit (% of GDP) of Namibia in 2014?
Keep it short and to the point. -9.34. What is the difference between the Domestic credit (% of GDP) in Latin America(all income levels) in 2010 and the Domestic credit (% of GDP) in Oman in 2014?
Provide a short and direct response. -6.68. What is the difference between the Domestic credit (% of GDP) in Latin America(all income levels) in 2010 and the Domestic credit (% of GDP) in Sierra Leone in 2014?
Offer a terse response. 34.92. What is the difference between the Domestic credit (% of GDP) of Namibia in 2010 and the Domestic credit (% of GDP) of Oman in 2014?
Make the answer very short. 2.67. What is the difference between the Domestic credit (% of GDP) of Namibia in 2010 and the Domestic credit (% of GDP) of Sierra Leone in 2014?
Your response must be concise. 44.27. What is the difference between the Domestic credit (% of GDP) in Oman in 2010 and the Domestic credit (% of GDP) in Sierra Leone in 2014?
Your answer should be compact. 37.5. What is the difference between the Domestic credit (% of GDP) in Latin America(all income levels) in 2011 and the Domestic credit (% of GDP) in Namibia in 2012?
Offer a terse response. -4.39. What is the difference between the Domestic credit (% of GDP) of Latin America(all income levels) in 2011 and the Domestic credit (% of GDP) of Oman in 2012?
Provide a succinct answer. 2.07. What is the difference between the Domestic credit (% of GDP) in Latin America(all income levels) in 2011 and the Domestic credit (% of GDP) in Sierra Leone in 2012?
Offer a terse response. 37.93. What is the difference between the Domestic credit (% of GDP) in Namibia in 2011 and the Domestic credit (% of GDP) in Oman in 2012?
Your answer should be very brief. 7.15. What is the difference between the Domestic credit (% of GDP) in Namibia in 2011 and the Domestic credit (% of GDP) in Sierra Leone in 2012?
Your response must be concise. 43.01. What is the difference between the Domestic credit (% of GDP) of Oman in 2011 and the Domestic credit (% of GDP) of Sierra Leone in 2012?
Your response must be concise. 34.89. What is the difference between the Domestic credit (% of GDP) in Latin America(all income levels) in 2011 and the Domestic credit (% of GDP) in Namibia in 2013?
Keep it short and to the point. -4.06. What is the difference between the Domestic credit (% of GDP) of Latin America(all income levels) in 2011 and the Domestic credit (% of GDP) of Oman in 2013?
Your answer should be very brief. 0.74. What is the difference between the Domestic credit (% of GDP) of Latin America(all income levels) in 2011 and the Domestic credit (% of GDP) of Sierra Leone in 2013?
Your response must be concise. 39.41. What is the difference between the Domestic credit (% of GDP) of Namibia in 2011 and the Domestic credit (% of GDP) of Oman in 2013?
Ensure brevity in your answer.  5.82. What is the difference between the Domestic credit (% of GDP) of Namibia in 2011 and the Domestic credit (% of GDP) of Sierra Leone in 2013?
Offer a very short reply. 44.5. What is the difference between the Domestic credit (% of GDP) of Oman in 2011 and the Domestic credit (% of GDP) of Sierra Leone in 2013?
Your answer should be compact. 36.37. What is the difference between the Domestic credit (% of GDP) in Latin America(all income levels) in 2011 and the Domestic credit (% of GDP) in Namibia in 2014?
Your response must be concise. -4.89. What is the difference between the Domestic credit (% of GDP) in Latin America(all income levels) in 2011 and the Domestic credit (% of GDP) in Oman in 2014?
Provide a succinct answer. -2.23. What is the difference between the Domestic credit (% of GDP) in Latin America(all income levels) in 2011 and the Domestic credit (% of GDP) in Sierra Leone in 2014?
Your answer should be compact. 39.37. What is the difference between the Domestic credit (% of GDP) of Namibia in 2011 and the Domestic credit (% of GDP) of Oman in 2014?
Provide a short and direct response. 2.85. What is the difference between the Domestic credit (% of GDP) of Namibia in 2011 and the Domestic credit (% of GDP) of Sierra Leone in 2014?
Offer a terse response. 44.45. What is the difference between the Domestic credit (% of GDP) of Oman in 2011 and the Domestic credit (% of GDP) of Sierra Leone in 2014?
Ensure brevity in your answer.  36.33. What is the difference between the Domestic credit (% of GDP) in Latin America(all income levels) in 2012 and the Domestic credit (% of GDP) in Namibia in 2013?
Your response must be concise. -1.13. What is the difference between the Domestic credit (% of GDP) in Latin America(all income levels) in 2012 and the Domestic credit (% of GDP) in Oman in 2013?
Your answer should be compact. 3.67. What is the difference between the Domestic credit (% of GDP) of Latin America(all income levels) in 2012 and the Domestic credit (% of GDP) of Sierra Leone in 2013?
Give a very brief answer. 42.35. What is the difference between the Domestic credit (% of GDP) in Namibia in 2012 and the Domestic credit (% of GDP) in Oman in 2013?
Give a very brief answer. 5.13. What is the difference between the Domestic credit (% of GDP) of Namibia in 2012 and the Domestic credit (% of GDP) of Sierra Leone in 2013?
Provide a short and direct response. 43.8. What is the difference between the Domestic credit (% of GDP) of Oman in 2012 and the Domestic credit (% of GDP) of Sierra Leone in 2013?
Your answer should be very brief. 37.35. What is the difference between the Domestic credit (% of GDP) in Latin America(all income levels) in 2012 and the Domestic credit (% of GDP) in Namibia in 2014?
Provide a short and direct response. -1.95. What is the difference between the Domestic credit (% of GDP) in Latin America(all income levels) in 2012 and the Domestic credit (% of GDP) in Oman in 2014?
Provide a short and direct response. 0.71. What is the difference between the Domestic credit (% of GDP) in Latin America(all income levels) in 2012 and the Domestic credit (% of GDP) in Sierra Leone in 2014?
Keep it short and to the point. 42.31. What is the difference between the Domestic credit (% of GDP) in Namibia in 2012 and the Domestic credit (% of GDP) in Oman in 2014?
Provide a succinct answer. 2.16. What is the difference between the Domestic credit (% of GDP) of Namibia in 2012 and the Domestic credit (% of GDP) of Sierra Leone in 2014?
Your answer should be compact. 43.76. What is the difference between the Domestic credit (% of GDP) in Oman in 2012 and the Domestic credit (% of GDP) in Sierra Leone in 2014?
Keep it short and to the point. 37.3. What is the difference between the Domestic credit (% of GDP) in Latin America(all income levels) in 2013 and the Domestic credit (% of GDP) in Namibia in 2014?
Your response must be concise. 1.54. What is the difference between the Domestic credit (% of GDP) of Latin America(all income levels) in 2013 and the Domestic credit (% of GDP) of Oman in 2014?
Your response must be concise. 4.2. What is the difference between the Domestic credit (% of GDP) in Latin America(all income levels) in 2013 and the Domestic credit (% of GDP) in Sierra Leone in 2014?
Make the answer very short. 45.8. What is the difference between the Domestic credit (% of GDP) of Namibia in 2013 and the Domestic credit (% of GDP) of Oman in 2014?
Offer a very short reply. 1.83. What is the difference between the Domestic credit (% of GDP) in Namibia in 2013 and the Domestic credit (% of GDP) in Sierra Leone in 2014?
Provide a short and direct response. 43.43. What is the difference between the Domestic credit (% of GDP) in Oman in 2013 and the Domestic credit (% of GDP) in Sierra Leone in 2014?
Keep it short and to the point. 38.64. What is the average Domestic credit (% of GDP) of Latin America(all income levels) per year?
Make the answer very short. 42.33. What is the average Domestic credit (% of GDP) of Namibia per year?
Ensure brevity in your answer.  48.59. What is the average Domestic credit (% of GDP) in Oman per year?
Offer a very short reply. 41.61. What is the average Domestic credit (% of GDP) in Sierra Leone per year?
Offer a terse response. 6.17. In the year 2007, what is the difference between the Domestic credit (% of GDP) in Latin America(all income levels) and Domestic credit (% of GDP) in Namibia?
Offer a very short reply. -15.59. In the year 2007, what is the difference between the Domestic credit (% of GDP) in Latin America(all income levels) and Domestic credit (% of GDP) in Oman?
Your answer should be very brief. -2.82. In the year 2007, what is the difference between the Domestic credit (% of GDP) in Latin America(all income levels) and Domestic credit (% of GDP) in Sierra Leone?
Offer a terse response. 28.42. In the year 2007, what is the difference between the Domestic credit (% of GDP) of Namibia and Domestic credit (% of GDP) of Oman?
Your answer should be compact. 12.77. In the year 2007, what is the difference between the Domestic credit (% of GDP) of Namibia and Domestic credit (% of GDP) of Sierra Leone?
Provide a short and direct response. 44.01. In the year 2007, what is the difference between the Domestic credit (% of GDP) in Oman and Domestic credit (% of GDP) in Sierra Leone?
Give a very brief answer. 31.24. In the year 2008, what is the difference between the Domestic credit (% of GDP) of Latin America(all income levels) and Domestic credit (% of GDP) of Namibia?
Provide a succinct answer. -12.4. In the year 2008, what is the difference between the Domestic credit (% of GDP) in Latin America(all income levels) and Domestic credit (% of GDP) in Oman?
Offer a very short reply. -0.05. In the year 2008, what is the difference between the Domestic credit (% of GDP) in Latin America(all income levels) and Domestic credit (% of GDP) in Sierra Leone?
Offer a very short reply. 29.52. In the year 2008, what is the difference between the Domestic credit (% of GDP) of Namibia and Domestic credit (% of GDP) of Oman?
Give a very brief answer. 12.35. In the year 2008, what is the difference between the Domestic credit (% of GDP) of Namibia and Domestic credit (% of GDP) of Sierra Leone?
Your answer should be very brief. 41.92. In the year 2008, what is the difference between the Domestic credit (% of GDP) of Oman and Domestic credit (% of GDP) of Sierra Leone?
Provide a short and direct response. 29.57. In the year 2009, what is the difference between the Domestic credit (% of GDP) of Latin America(all income levels) and Domestic credit (% of GDP) of Namibia?
Provide a succinct answer. -11.64. In the year 2009, what is the difference between the Domestic credit (% of GDP) of Latin America(all income levels) and Domestic credit (% of GDP) of Oman?
Ensure brevity in your answer.  -9.7. In the year 2009, what is the difference between the Domestic credit (% of GDP) of Latin America(all income levels) and Domestic credit (% of GDP) of Sierra Leone?
Make the answer very short. 28.82. In the year 2009, what is the difference between the Domestic credit (% of GDP) in Namibia and Domestic credit (% of GDP) in Oman?
Keep it short and to the point. 1.94. In the year 2009, what is the difference between the Domestic credit (% of GDP) in Namibia and Domestic credit (% of GDP) in Sierra Leone?
Provide a short and direct response. 40.46. In the year 2009, what is the difference between the Domestic credit (% of GDP) of Oman and Domestic credit (% of GDP) of Sierra Leone?
Your answer should be very brief. 38.52. In the year 2010, what is the difference between the Domestic credit (% of GDP) in Latin America(all income levels) and Domestic credit (% of GDP) in Namibia?
Ensure brevity in your answer.  -9.36. In the year 2010, what is the difference between the Domestic credit (% of GDP) in Latin America(all income levels) and Domestic credit (% of GDP) in Oman?
Ensure brevity in your answer.  -2.58. In the year 2010, what is the difference between the Domestic credit (% of GDP) in Latin America(all income levels) and Domestic credit (% of GDP) in Sierra Leone?
Offer a very short reply. 31.98. In the year 2010, what is the difference between the Domestic credit (% of GDP) in Namibia and Domestic credit (% of GDP) in Oman?
Your answer should be very brief. 6.78. In the year 2010, what is the difference between the Domestic credit (% of GDP) of Namibia and Domestic credit (% of GDP) of Sierra Leone?
Your response must be concise. 41.34. In the year 2010, what is the difference between the Domestic credit (% of GDP) of Oman and Domestic credit (% of GDP) of Sierra Leone?
Offer a very short reply. 34.56. In the year 2011, what is the difference between the Domestic credit (% of GDP) in Latin America(all income levels) and Domestic credit (% of GDP) in Namibia?
Make the answer very short. -5.08. In the year 2011, what is the difference between the Domestic credit (% of GDP) in Latin America(all income levels) and Domestic credit (% of GDP) in Oman?
Your response must be concise. 3.04. In the year 2011, what is the difference between the Domestic credit (% of GDP) in Latin America(all income levels) and Domestic credit (% of GDP) in Sierra Leone?
Ensure brevity in your answer.  36.48. In the year 2011, what is the difference between the Domestic credit (% of GDP) in Namibia and Domestic credit (% of GDP) in Oman?
Make the answer very short. 8.12. In the year 2011, what is the difference between the Domestic credit (% of GDP) of Namibia and Domestic credit (% of GDP) of Sierra Leone?
Offer a terse response. 41.56. In the year 2011, what is the difference between the Domestic credit (% of GDP) of Oman and Domestic credit (% of GDP) of Sierra Leone?
Give a very brief answer. 33.43. In the year 2012, what is the difference between the Domestic credit (% of GDP) in Latin America(all income levels) and Domestic credit (% of GDP) in Namibia?
Keep it short and to the point. -1.45. In the year 2012, what is the difference between the Domestic credit (% of GDP) in Latin America(all income levels) and Domestic credit (% of GDP) in Oman?
Your answer should be compact. 5.01. In the year 2012, what is the difference between the Domestic credit (% of GDP) of Latin America(all income levels) and Domestic credit (% of GDP) of Sierra Leone?
Your answer should be compact. 40.87. In the year 2012, what is the difference between the Domestic credit (% of GDP) of Namibia and Domestic credit (% of GDP) of Oman?
Offer a very short reply. 6.46. In the year 2012, what is the difference between the Domestic credit (% of GDP) in Namibia and Domestic credit (% of GDP) in Sierra Leone?
Your answer should be compact. 42.32. In the year 2012, what is the difference between the Domestic credit (% of GDP) of Oman and Domestic credit (% of GDP) of Sierra Leone?
Your answer should be very brief. 35.86. In the year 2013, what is the difference between the Domestic credit (% of GDP) in Latin America(all income levels) and Domestic credit (% of GDP) in Namibia?
Make the answer very short. 2.36. In the year 2013, what is the difference between the Domestic credit (% of GDP) in Latin America(all income levels) and Domestic credit (% of GDP) in Oman?
Ensure brevity in your answer.  7.16. In the year 2013, what is the difference between the Domestic credit (% of GDP) in Latin America(all income levels) and Domestic credit (% of GDP) in Sierra Leone?
Provide a short and direct response. 45.84. In the year 2013, what is the difference between the Domestic credit (% of GDP) in Namibia and Domestic credit (% of GDP) in Oman?
Give a very brief answer. 4.8. In the year 2013, what is the difference between the Domestic credit (% of GDP) of Namibia and Domestic credit (% of GDP) of Sierra Leone?
Keep it short and to the point. 43.48. In the year 2013, what is the difference between the Domestic credit (% of GDP) of Oman and Domestic credit (% of GDP) of Sierra Leone?
Provide a short and direct response. 38.68. In the year 2014, what is the difference between the Domestic credit (% of GDP) in Latin America(all income levels) and Domestic credit (% of GDP) in Namibia?
Offer a very short reply. 3.05. In the year 2014, what is the difference between the Domestic credit (% of GDP) of Latin America(all income levels) and Domestic credit (% of GDP) of Oman?
Give a very brief answer. 5.71. In the year 2014, what is the difference between the Domestic credit (% of GDP) of Latin America(all income levels) and Domestic credit (% of GDP) of Sierra Leone?
Make the answer very short. 47.31. In the year 2014, what is the difference between the Domestic credit (% of GDP) in Namibia and Domestic credit (% of GDP) in Oman?
Provide a succinct answer. 2.66. In the year 2014, what is the difference between the Domestic credit (% of GDP) in Namibia and Domestic credit (% of GDP) in Sierra Leone?
Your response must be concise. 44.26. In the year 2014, what is the difference between the Domestic credit (% of GDP) of Oman and Domestic credit (% of GDP) of Sierra Leone?
Your answer should be compact. 41.6. What is the ratio of the Domestic credit (% of GDP) in Latin America(all income levels) in 2007 to that in 2008?
Ensure brevity in your answer.  0.93. What is the ratio of the Domestic credit (% of GDP) in Namibia in 2007 to that in 2008?
Make the answer very short. 1.02. What is the ratio of the Domestic credit (% of GDP) in Oman in 2007 to that in 2008?
Your answer should be very brief. 1.01. What is the ratio of the Domestic credit (% of GDP) in Sierra Leone in 2007 to that in 2008?
Offer a very short reply. 0.77. What is the ratio of the Domestic credit (% of GDP) of Latin America(all income levels) in 2007 to that in 2009?
Make the answer very short. 0.88. What is the ratio of the Domestic credit (% of GDP) of Namibia in 2007 to that in 2009?
Offer a terse response. 0.99. What is the ratio of the Domestic credit (% of GDP) in Oman in 2007 to that in 2009?
Your answer should be very brief. 0.76. What is the ratio of the Domestic credit (% of GDP) in Sierra Leone in 2007 to that in 2009?
Keep it short and to the point. 0.53. What is the ratio of the Domestic credit (% of GDP) of Latin America(all income levels) in 2007 to that in 2010?
Your answer should be compact. 0.82. What is the ratio of the Domestic credit (% of GDP) in Namibia in 2007 to that in 2010?
Provide a short and direct response. 0.98. What is the ratio of the Domestic credit (% of GDP) of Oman in 2007 to that in 2010?
Your answer should be very brief. 0.84. What is the ratio of the Domestic credit (% of GDP) in Sierra Leone in 2007 to that in 2010?
Make the answer very short. 0.55. What is the ratio of the Domestic credit (% of GDP) in Latin America(all income levels) in 2007 to that in 2011?
Give a very brief answer. 0.74. What is the ratio of the Domestic credit (% of GDP) in Namibia in 2007 to that in 2011?
Keep it short and to the point. 0.98. What is the ratio of the Domestic credit (% of GDP) of Oman in 2007 to that in 2011?
Your response must be concise. 0.86. What is the ratio of the Domestic credit (% of GDP) in Sierra Leone in 2007 to that in 2011?
Make the answer very short. 0.55. What is the ratio of the Domestic credit (% of GDP) in Latin America(all income levels) in 2007 to that in 2012?
Provide a succinct answer. 0.69. What is the ratio of the Domestic credit (% of GDP) in Oman in 2007 to that in 2012?
Provide a short and direct response. 0.84. What is the ratio of the Domestic credit (% of GDP) of Sierra Leone in 2007 to that in 2012?
Give a very brief answer. 0.68. What is the ratio of the Domestic credit (% of GDP) in Latin America(all income levels) in 2007 to that in 2013?
Ensure brevity in your answer.  0.65. What is the ratio of the Domestic credit (% of GDP) in Oman in 2007 to that in 2013?
Provide a succinct answer. 0.82. What is the ratio of the Domestic credit (% of GDP) of Sierra Leone in 2007 to that in 2013?
Your answer should be very brief. 0.89. What is the ratio of the Domestic credit (% of GDP) in Latin America(all income levels) in 2007 to that in 2014?
Your answer should be compact. 0.63. What is the ratio of the Domestic credit (% of GDP) in Namibia in 2007 to that in 2014?
Your answer should be very brief. 0.98. What is the ratio of the Domestic credit (% of GDP) of Oman in 2007 to that in 2014?
Your answer should be compact. 0.77. What is the ratio of the Domestic credit (% of GDP) of Sierra Leone in 2007 to that in 2014?
Your response must be concise. 0.89. What is the ratio of the Domestic credit (% of GDP) of Latin America(all income levels) in 2008 to that in 2009?
Offer a very short reply. 0.95. What is the ratio of the Domestic credit (% of GDP) in Namibia in 2008 to that in 2009?
Offer a terse response. 0.98. What is the ratio of the Domestic credit (% of GDP) in Oman in 2008 to that in 2009?
Your response must be concise. 0.75. What is the ratio of the Domestic credit (% of GDP) of Sierra Leone in 2008 to that in 2009?
Give a very brief answer. 0.68. What is the ratio of the Domestic credit (% of GDP) in Latin America(all income levels) in 2008 to that in 2010?
Your response must be concise. 0.88. What is the ratio of the Domestic credit (% of GDP) in Namibia in 2008 to that in 2010?
Your answer should be compact. 0.97. What is the ratio of the Domestic credit (% of GDP) of Oman in 2008 to that in 2010?
Make the answer very short. 0.83. What is the ratio of the Domestic credit (% of GDP) of Sierra Leone in 2008 to that in 2010?
Make the answer very short. 0.71. What is the ratio of the Domestic credit (% of GDP) in Latin America(all income levels) in 2008 to that in 2011?
Offer a terse response. 0.79. What is the ratio of the Domestic credit (% of GDP) of Namibia in 2008 to that in 2011?
Ensure brevity in your answer.  0.96. What is the ratio of the Domestic credit (% of GDP) of Oman in 2008 to that in 2011?
Keep it short and to the point. 0.85. What is the ratio of the Domestic credit (% of GDP) of Sierra Leone in 2008 to that in 2011?
Your answer should be compact. 0.72. What is the ratio of the Domestic credit (% of GDP) of Latin America(all income levels) in 2008 to that in 2012?
Your response must be concise. 0.74. What is the ratio of the Domestic credit (% of GDP) in Namibia in 2008 to that in 2012?
Offer a very short reply. 0.98. What is the ratio of the Domestic credit (% of GDP) of Oman in 2008 to that in 2012?
Your response must be concise. 0.83. What is the ratio of the Domestic credit (% of GDP) in Sierra Leone in 2008 to that in 2012?
Keep it short and to the point. 0.88. What is the ratio of the Domestic credit (% of GDP) of Latin America(all income levels) in 2008 to that in 2013?
Offer a very short reply. 0.69. What is the ratio of the Domestic credit (% of GDP) of Namibia in 2008 to that in 2013?
Keep it short and to the point. 0.98. What is the ratio of the Domestic credit (% of GDP) of Oman in 2008 to that in 2013?
Your answer should be very brief. 0.81. What is the ratio of the Domestic credit (% of GDP) of Sierra Leone in 2008 to that in 2013?
Keep it short and to the point. 1.16. What is the ratio of the Domestic credit (% of GDP) in Latin America(all income levels) in 2008 to that in 2014?
Give a very brief answer. 0.67. What is the ratio of the Domestic credit (% of GDP) in Namibia in 2008 to that in 2014?
Your answer should be very brief. 0.97. What is the ratio of the Domestic credit (% of GDP) of Oman in 2008 to that in 2014?
Provide a succinct answer. 0.76. What is the ratio of the Domestic credit (% of GDP) of Sierra Leone in 2008 to that in 2014?
Your answer should be compact. 1.14. What is the ratio of the Domestic credit (% of GDP) of Latin America(all income levels) in 2009 to that in 2010?
Provide a succinct answer. 0.93. What is the ratio of the Domestic credit (% of GDP) of Namibia in 2009 to that in 2010?
Keep it short and to the point. 0.99. What is the ratio of the Domestic credit (% of GDP) in Oman in 2009 to that in 2010?
Give a very brief answer. 1.1. What is the ratio of the Domestic credit (% of GDP) in Sierra Leone in 2009 to that in 2010?
Give a very brief answer. 1.05. What is the ratio of the Domestic credit (% of GDP) of Latin America(all income levels) in 2009 to that in 2011?
Provide a short and direct response. 0.84. What is the ratio of the Domestic credit (% of GDP) in Namibia in 2009 to that in 2011?
Your answer should be very brief. 0.99. What is the ratio of the Domestic credit (% of GDP) in Oman in 2009 to that in 2011?
Keep it short and to the point. 1.13. What is the ratio of the Domestic credit (% of GDP) in Sierra Leone in 2009 to that in 2011?
Provide a succinct answer. 1.06. What is the ratio of the Domestic credit (% of GDP) of Latin America(all income levels) in 2009 to that in 2012?
Offer a terse response. 0.78. What is the ratio of the Domestic credit (% of GDP) in Oman in 2009 to that in 2012?
Your answer should be very brief. 1.11. What is the ratio of the Domestic credit (% of GDP) in Sierra Leone in 2009 to that in 2012?
Make the answer very short. 1.3. What is the ratio of the Domestic credit (% of GDP) of Latin America(all income levels) in 2009 to that in 2013?
Offer a terse response. 0.73. What is the ratio of the Domestic credit (% of GDP) in Namibia in 2009 to that in 2013?
Offer a very short reply. 1.01. What is the ratio of the Domestic credit (% of GDP) in Oman in 2009 to that in 2013?
Make the answer very short. 1.07. What is the ratio of the Domestic credit (% of GDP) in Sierra Leone in 2009 to that in 2013?
Provide a short and direct response. 1.7. What is the ratio of the Domestic credit (% of GDP) in Latin America(all income levels) in 2009 to that in 2014?
Provide a short and direct response. 0.71. What is the ratio of the Domestic credit (% of GDP) in Namibia in 2009 to that in 2014?
Offer a terse response. 0.99. What is the ratio of the Domestic credit (% of GDP) in Oman in 2009 to that in 2014?
Your answer should be very brief. 1.01. What is the ratio of the Domestic credit (% of GDP) in Sierra Leone in 2009 to that in 2014?
Your response must be concise. 1.69. What is the ratio of the Domestic credit (% of GDP) of Latin America(all income levels) in 2010 to that in 2011?
Your answer should be compact. 0.9. What is the ratio of the Domestic credit (% of GDP) in Oman in 2010 to that in 2011?
Give a very brief answer. 1.03. What is the ratio of the Domestic credit (% of GDP) of Latin America(all income levels) in 2010 to that in 2012?
Provide a succinct answer. 0.84. What is the ratio of the Domestic credit (% of GDP) of Namibia in 2010 to that in 2012?
Make the answer very short. 1.01. What is the ratio of the Domestic credit (% of GDP) in Sierra Leone in 2010 to that in 2012?
Give a very brief answer. 1.24. What is the ratio of the Domestic credit (% of GDP) in Latin America(all income levels) in 2010 to that in 2013?
Offer a very short reply. 0.79. What is the ratio of the Domestic credit (% of GDP) in Namibia in 2010 to that in 2013?
Make the answer very short. 1.02. What is the ratio of the Domestic credit (% of GDP) of Oman in 2010 to that in 2013?
Make the answer very short. 0.97. What is the ratio of the Domestic credit (% of GDP) in Sierra Leone in 2010 to that in 2013?
Your answer should be very brief. 1.62. What is the ratio of the Domestic credit (% of GDP) in Latin America(all income levels) in 2010 to that in 2014?
Offer a very short reply. 0.76. What is the ratio of the Domestic credit (% of GDP) in Namibia in 2010 to that in 2014?
Provide a short and direct response. 1. What is the ratio of the Domestic credit (% of GDP) in Oman in 2010 to that in 2014?
Provide a succinct answer. 0.91. What is the ratio of the Domestic credit (% of GDP) in Sierra Leone in 2010 to that in 2014?
Make the answer very short. 1.61. What is the ratio of the Domestic credit (% of GDP) in Latin America(all income levels) in 2011 to that in 2012?
Ensure brevity in your answer.  0.94. What is the ratio of the Domestic credit (% of GDP) of Namibia in 2011 to that in 2012?
Make the answer very short. 1.01. What is the ratio of the Domestic credit (% of GDP) of Oman in 2011 to that in 2012?
Provide a succinct answer. 0.98. What is the ratio of the Domestic credit (% of GDP) of Sierra Leone in 2011 to that in 2012?
Provide a succinct answer. 1.23. What is the ratio of the Domestic credit (% of GDP) in Latin America(all income levels) in 2011 to that in 2013?
Keep it short and to the point. 0.87. What is the ratio of the Domestic credit (% of GDP) of Namibia in 2011 to that in 2013?
Offer a very short reply. 1.02. What is the ratio of the Domestic credit (% of GDP) of Oman in 2011 to that in 2013?
Offer a terse response. 0.95. What is the ratio of the Domestic credit (% of GDP) in Sierra Leone in 2011 to that in 2013?
Provide a short and direct response. 1.61. What is the ratio of the Domestic credit (% of GDP) of Latin America(all income levels) in 2011 to that in 2014?
Your response must be concise. 0.85. What is the ratio of the Domestic credit (% of GDP) in Oman in 2011 to that in 2014?
Your answer should be compact. 0.89. What is the ratio of the Domestic credit (% of GDP) in Sierra Leone in 2011 to that in 2014?
Make the answer very short. 1.6. What is the ratio of the Domestic credit (% of GDP) in Latin America(all income levels) in 2012 to that in 2013?
Your response must be concise. 0.93. What is the ratio of the Domestic credit (% of GDP) in Namibia in 2012 to that in 2013?
Keep it short and to the point. 1.01. What is the ratio of the Domestic credit (% of GDP) in Oman in 2012 to that in 2013?
Ensure brevity in your answer.  0.97. What is the ratio of the Domestic credit (% of GDP) in Sierra Leone in 2012 to that in 2013?
Keep it short and to the point. 1.31. What is the ratio of the Domestic credit (% of GDP) in Latin America(all income levels) in 2012 to that in 2014?
Your answer should be very brief. 0.9. What is the ratio of the Domestic credit (% of GDP) of Namibia in 2012 to that in 2014?
Your answer should be compact. 0.99. What is the ratio of the Domestic credit (% of GDP) of Oman in 2012 to that in 2014?
Offer a very short reply. 0.91. What is the ratio of the Domestic credit (% of GDP) in Sierra Leone in 2012 to that in 2014?
Ensure brevity in your answer.  1.3. What is the ratio of the Domestic credit (% of GDP) of Namibia in 2013 to that in 2014?
Your answer should be very brief. 0.98. What is the ratio of the Domestic credit (% of GDP) in Oman in 2013 to that in 2014?
Provide a succinct answer. 0.94. What is the difference between the highest and the second highest Domestic credit (% of GDP) in Latin America(all income levels)?
Keep it short and to the point. 1.51. What is the difference between the highest and the second highest Domestic credit (% of GDP) in Namibia?
Provide a succinct answer. 0.18. What is the difference between the highest and the second highest Domestic credit (% of GDP) in Oman?
Provide a short and direct response. 0.24. What is the difference between the highest and the second highest Domestic credit (% of GDP) in Sierra Leone?
Provide a short and direct response. 0.39. What is the difference between the highest and the lowest Domestic credit (% of GDP) of Latin America(all income levels)?
Offer a terse response. 19.44. What is the difference between the highest and the lowest Domestic credit (% of GDP) in Namibia?
Your answer should be very brief. 1.83. What is the difference between the highest and the lowest Domestic credit (% of GDP) in Oman?
Offer a very short reply. 11.57. What is the difference between the highest and the lowest Domestic credit (% of GDP) of Sierra Leone?
Ensure brevity in your answer.  3.87. 